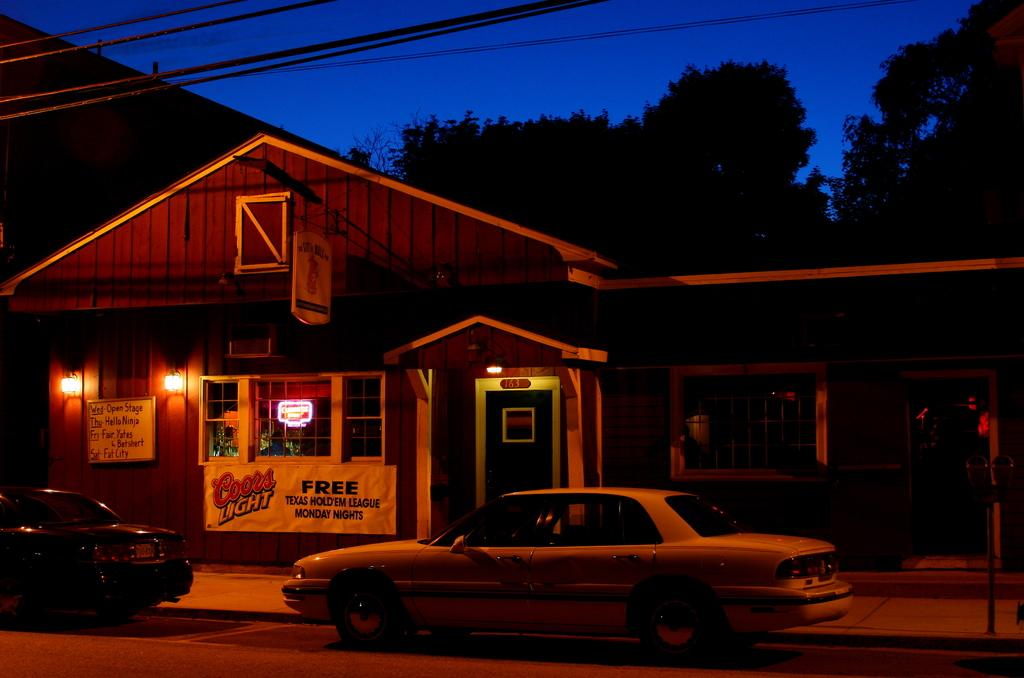What type of structure is visible in the image? There is a house in the image. What feature of the house is mentioned in the facts? The house has windows. What other objects can be seen in the image? There are boards with text, trees, cars, and lights in the image. What is visible in the background of the image? The sky is visible in the background of the image. What type of note is being played on the record in the image? There is no record or note being played in the image; it features a house, boards with text, trees, cars, lights, and a visible sky in the background. 